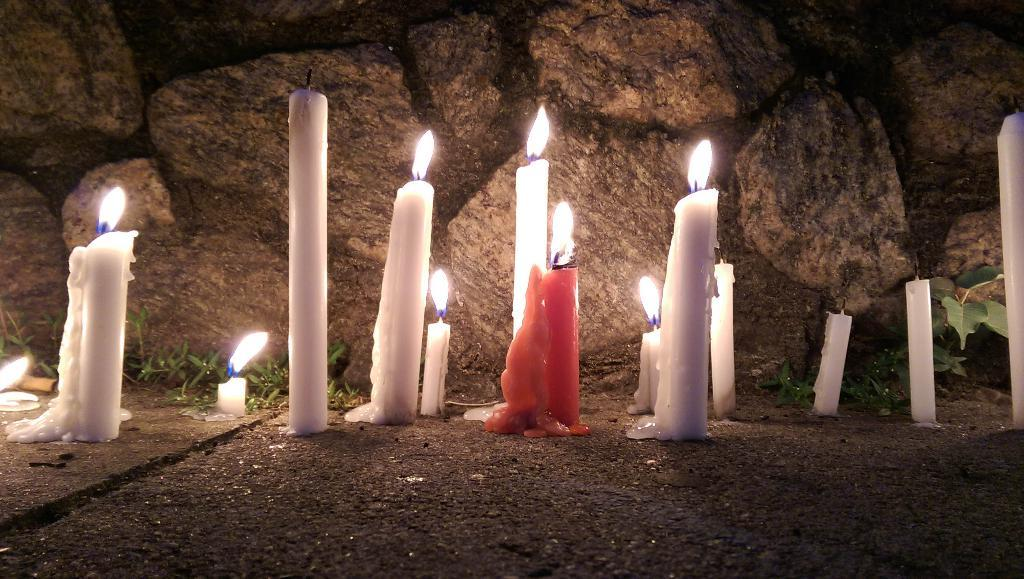What is the main subject in the center of the image? There are candles in the center of the image. What can be seen at the bottom of the image? There is a road at the bottom of the image. What type of natural feature is visible in the background of the image? There is a rock wall in the background of the image. What type of vegetation is visible in the background of the image? Grass is visible in the background of the image. Can you see friends walking down the hall in the image? There is no hall or friends present in the image. What type of carriage is parked next to the rock wall in the image? There is no carriage present in the image; only candles, a road, a rock wall, and grass are visible. 